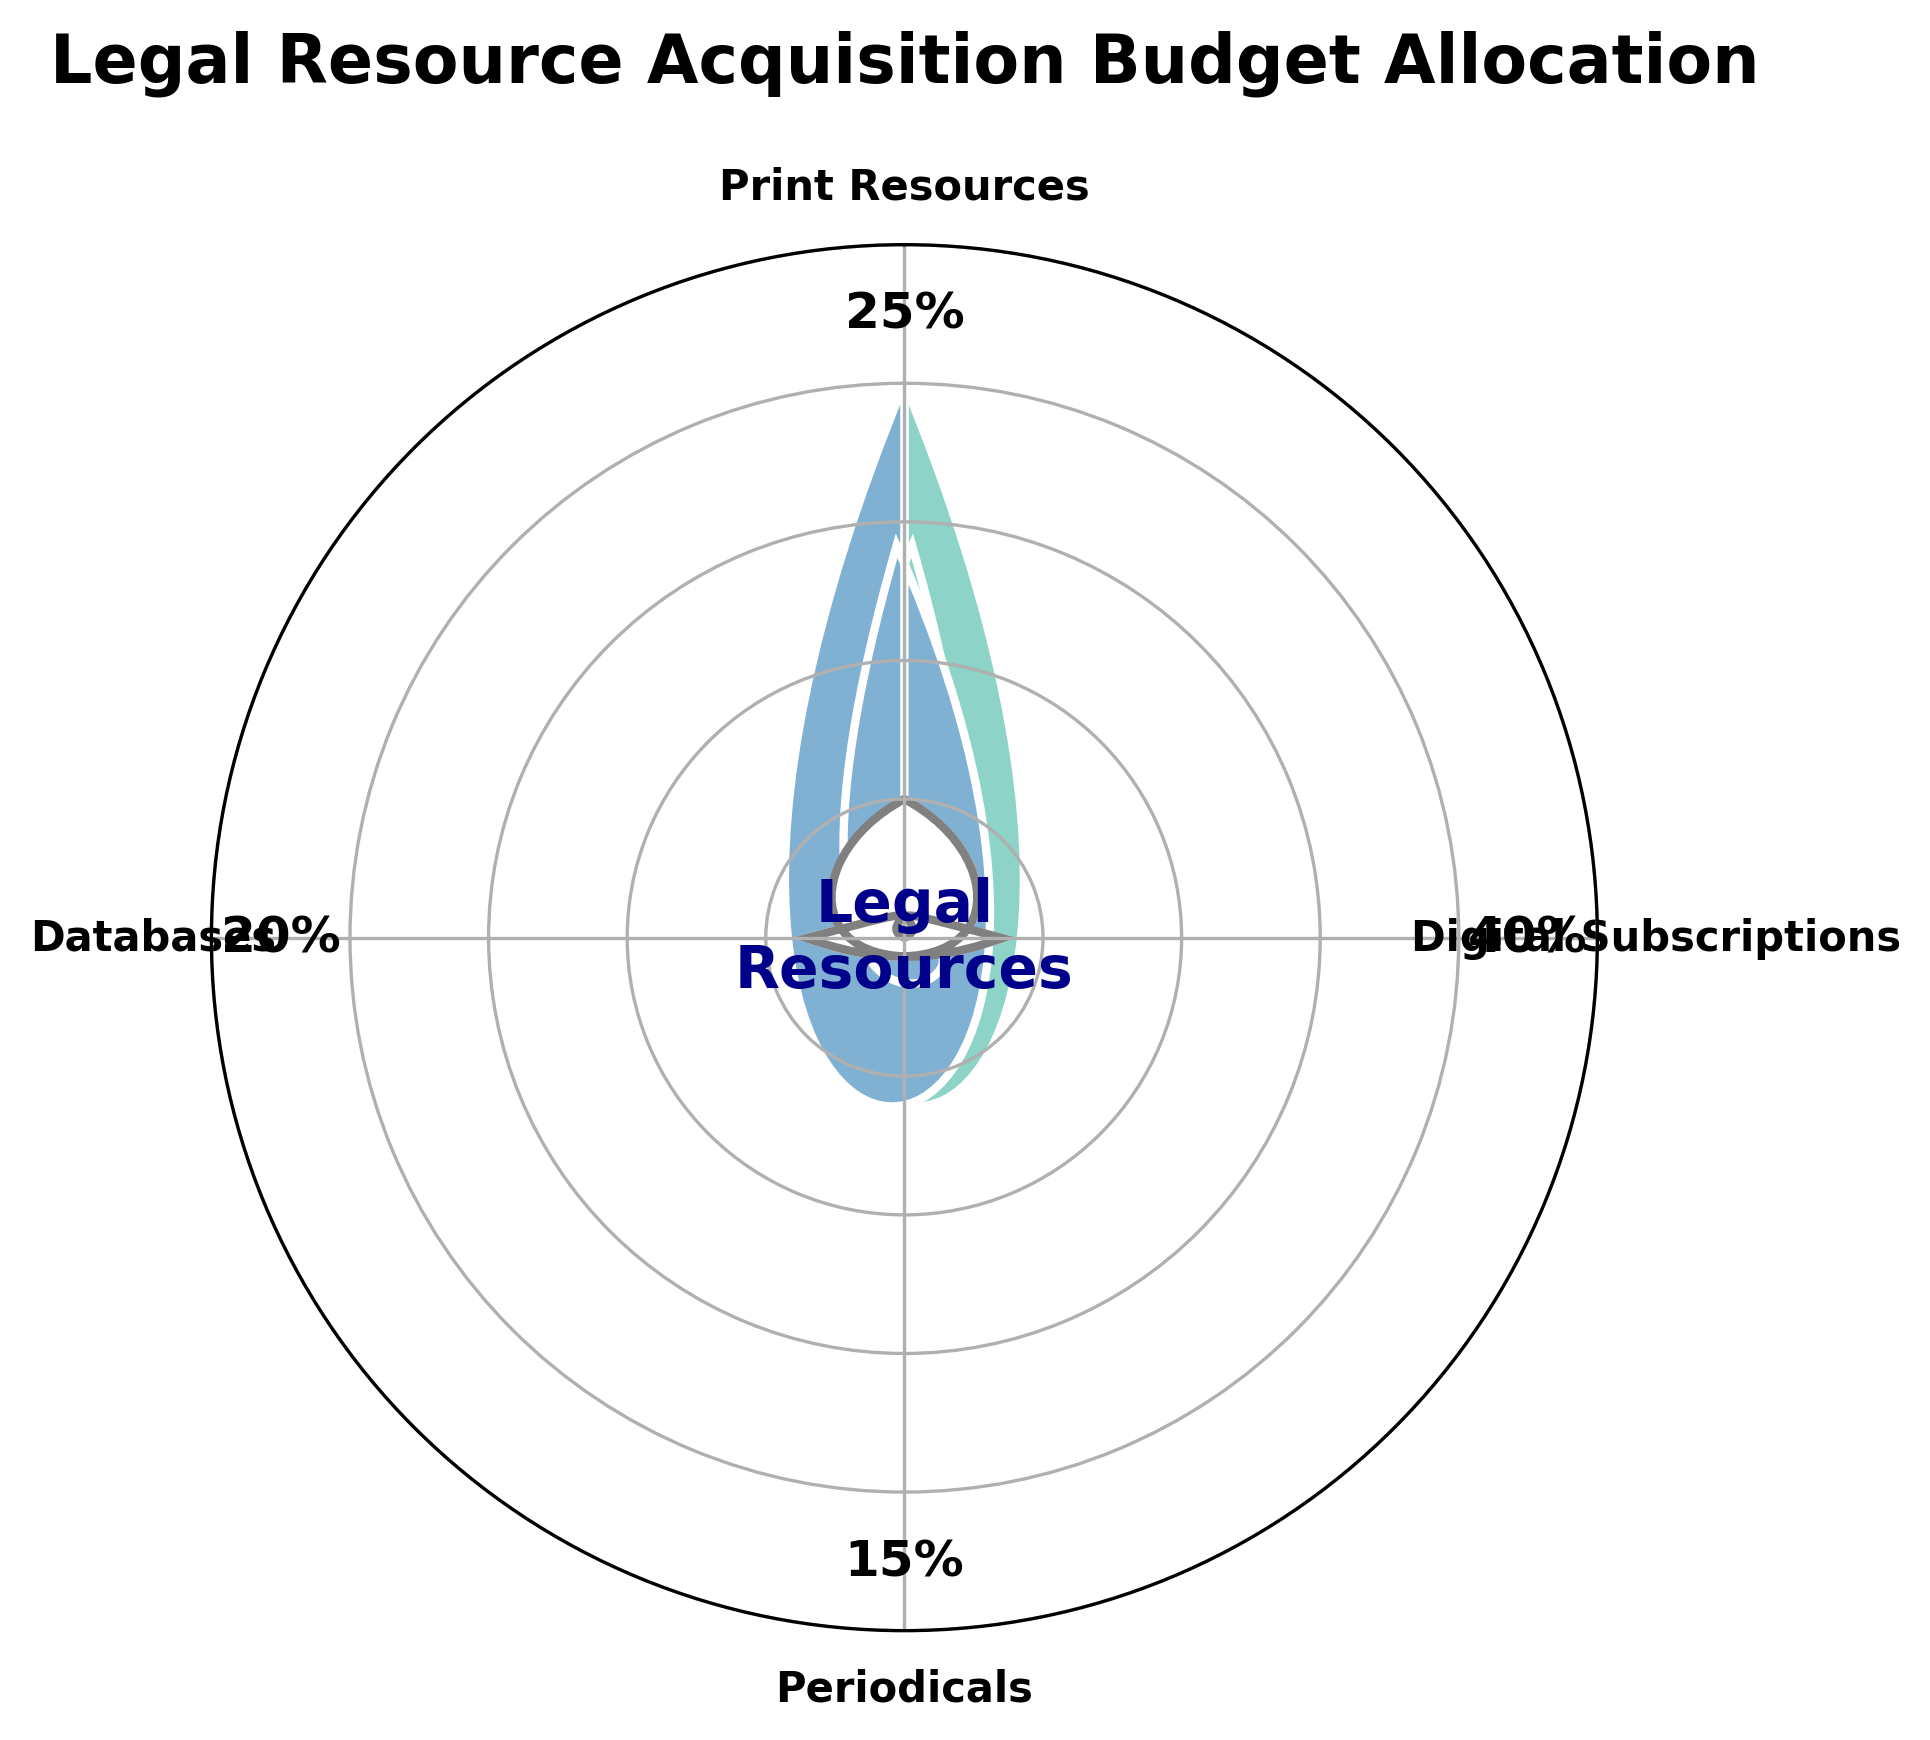What is the title of the figure? The title is usually found at the top of the plot and provides a summary of the content. In this case, it's "Legal Resource Acquisition Budget Allocation"
Answer: Legal Resource Acquisition Budget Allocation What is the percentage allocated to Print Resources? The percentage values are displayed alongside each segment of the gauge chart. The percentage for Print Resources is right next to its corresponding segment.
Answer: 25% How many categories are represented in the gauge chart? By counting the segments in the chart or the labels around the plot, we can see there are four distinct categories.
Answer: Four Which category has the highest percentage allocation? We can find the highest percentage by comparing all the percentage values in the chart. Digital Subscriptions have the highest allocation at 40%.
Answer: Digital Subscriptions What is the combined percentage of Periodicals and Databases? Adding the percentage of Periodicals (15%) and Databases (20%) gives us the combined percentage: 15% + 20% = 35%.
Answer: 35% Which category has a lower allocation: Print Resources or Periodicals? Comparing the percentages, Print Resources is at 25% and Periodicals is at 15%. Therefore, Periodicals has a lower allocation.
Answer: Periodicals What is the average percentage allocation across all categories? The total percentage is (25 + 40 + 15 + 20) = 100. The average is 100/4 = 25%.
Answer: 25% Is the allocation for Databases greater than the allocation for Print Resources? Comparing the two values, Databases have a 20% allocation whereas Print Resources have 25%, so Databases are not greater.
Answer: No What is the smallest percentage allocation in the chart? By inspecting all percentages, we see that Periodicals have the smallest allocation at 15%.
Answer: 15% How does the chart visually differentiate between different categories? Each category is represented by a different color, and the percentages are displayed next to their respective segments. The frequencies and the labels around the chart further clarify the distribution.
Answer: Different colors and labels 